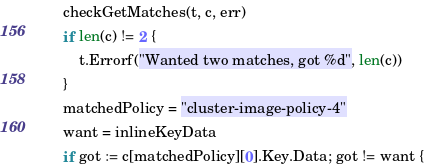Convert code to text. <code><loc_0><loc_0><loc_500><loc_500><_Go_>	checkGetMatches(t, c, err)
	if len(c) != 2 {
		t.Errorf("Wanted two matches, got %d", len(c))
	}
	matchedPolicy = "cluster-image-policy-4"
	want = inlineKeyData
	if got := c[matchedPolicy][0].Key.Data; got != want {</code> 